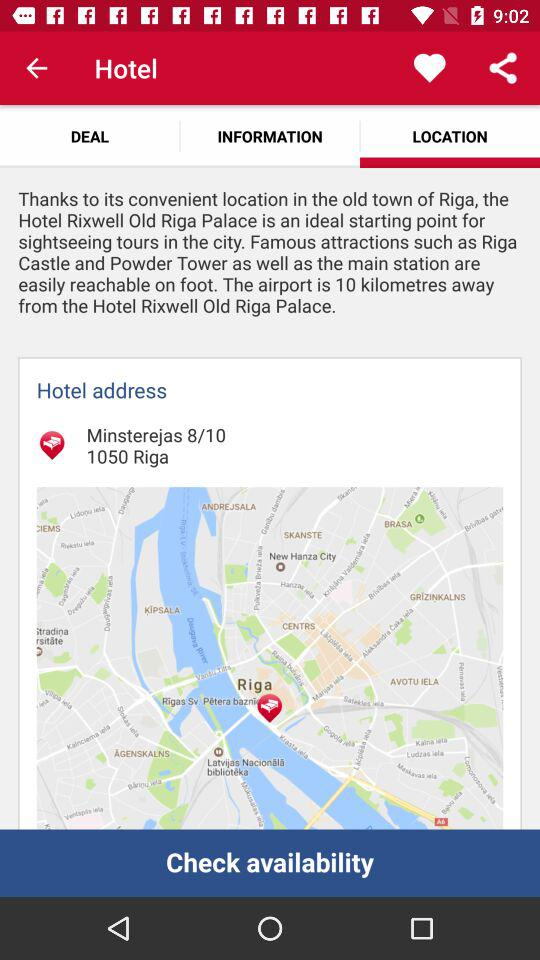How far is the airport from the hotel? The airport is 10 kilometres away from the hotel. 